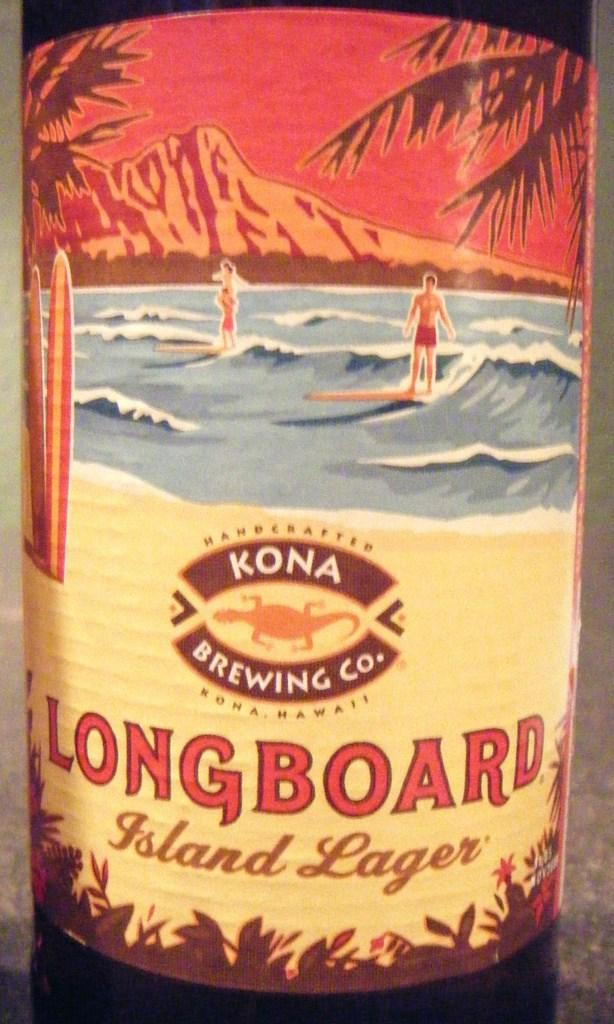<image>
Write a terse but informative summary of the picture. A bottle of long board from Kona Brewing company features surfers on the label. 